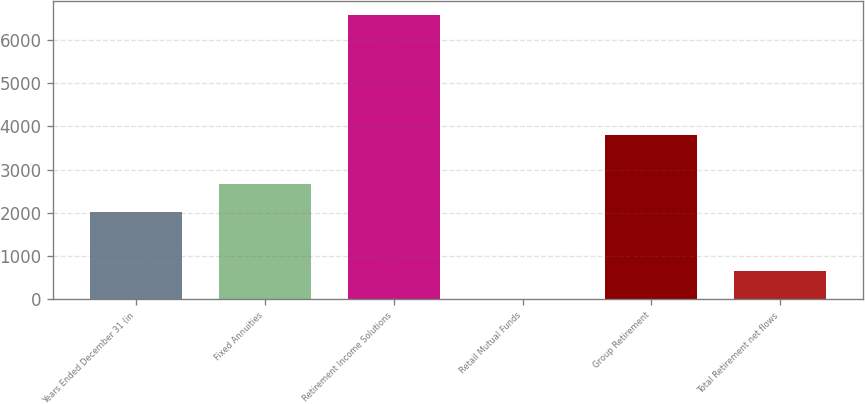Convert chart. <chart><loc_0><loc_0><loc_500><loc_500><bar_chart><fcel>Years Ended December 31 (in<fcel>Fixed Annuities<fcel>Retirement Income Solutions<fcel>Retail Mutual Funds<fcel>Group Retirement<fcel>Total Retirement net flows<nl><fcel>2014<fcel>2670.5<fcel>6566<fcel>1<fcel>3797<fcel>657.5<nl></chart> 